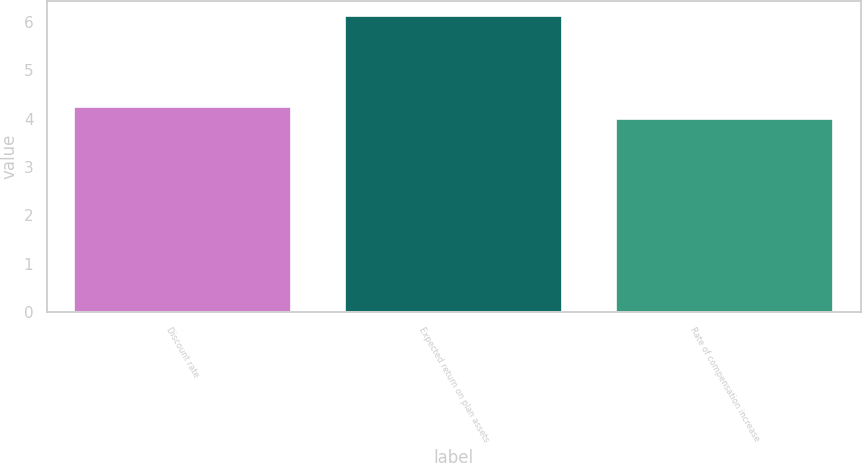Convert chart to OTSL. <chart><loc_0><loc_0><loc_500><loc_500><bar_chart><fcel>Discount rate<fcel>Expected return on plan assets<fcel>Rate of compensation increase<nl><fcel>4.25<fcel>6.13<fcel>4<nl></chart> 